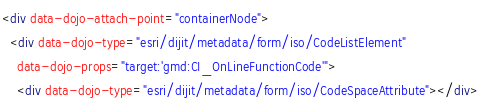<code> <loc_0><loc_0><loc_500><loc_500><_HTML_><div data-dojo-attach-point="containerNode">
  <div data-dojo-type="esri/dijit/metadata/form/iso/CodeListElement"
    data-dojo-props="target:'gmd:CI_OnLineFunctionCode'">
    <div data-dojo-type="esri/dijit/metadata/form/iso/CodeSpaceAttribute"></div></code> 